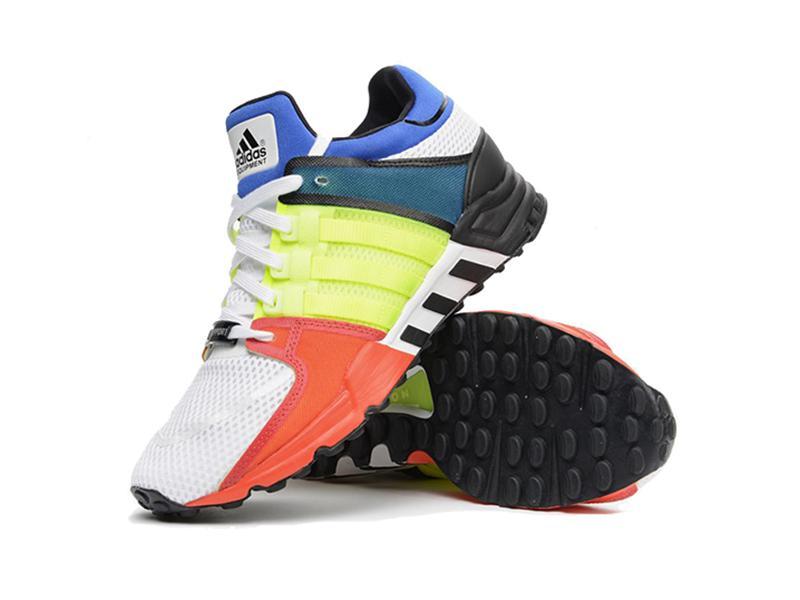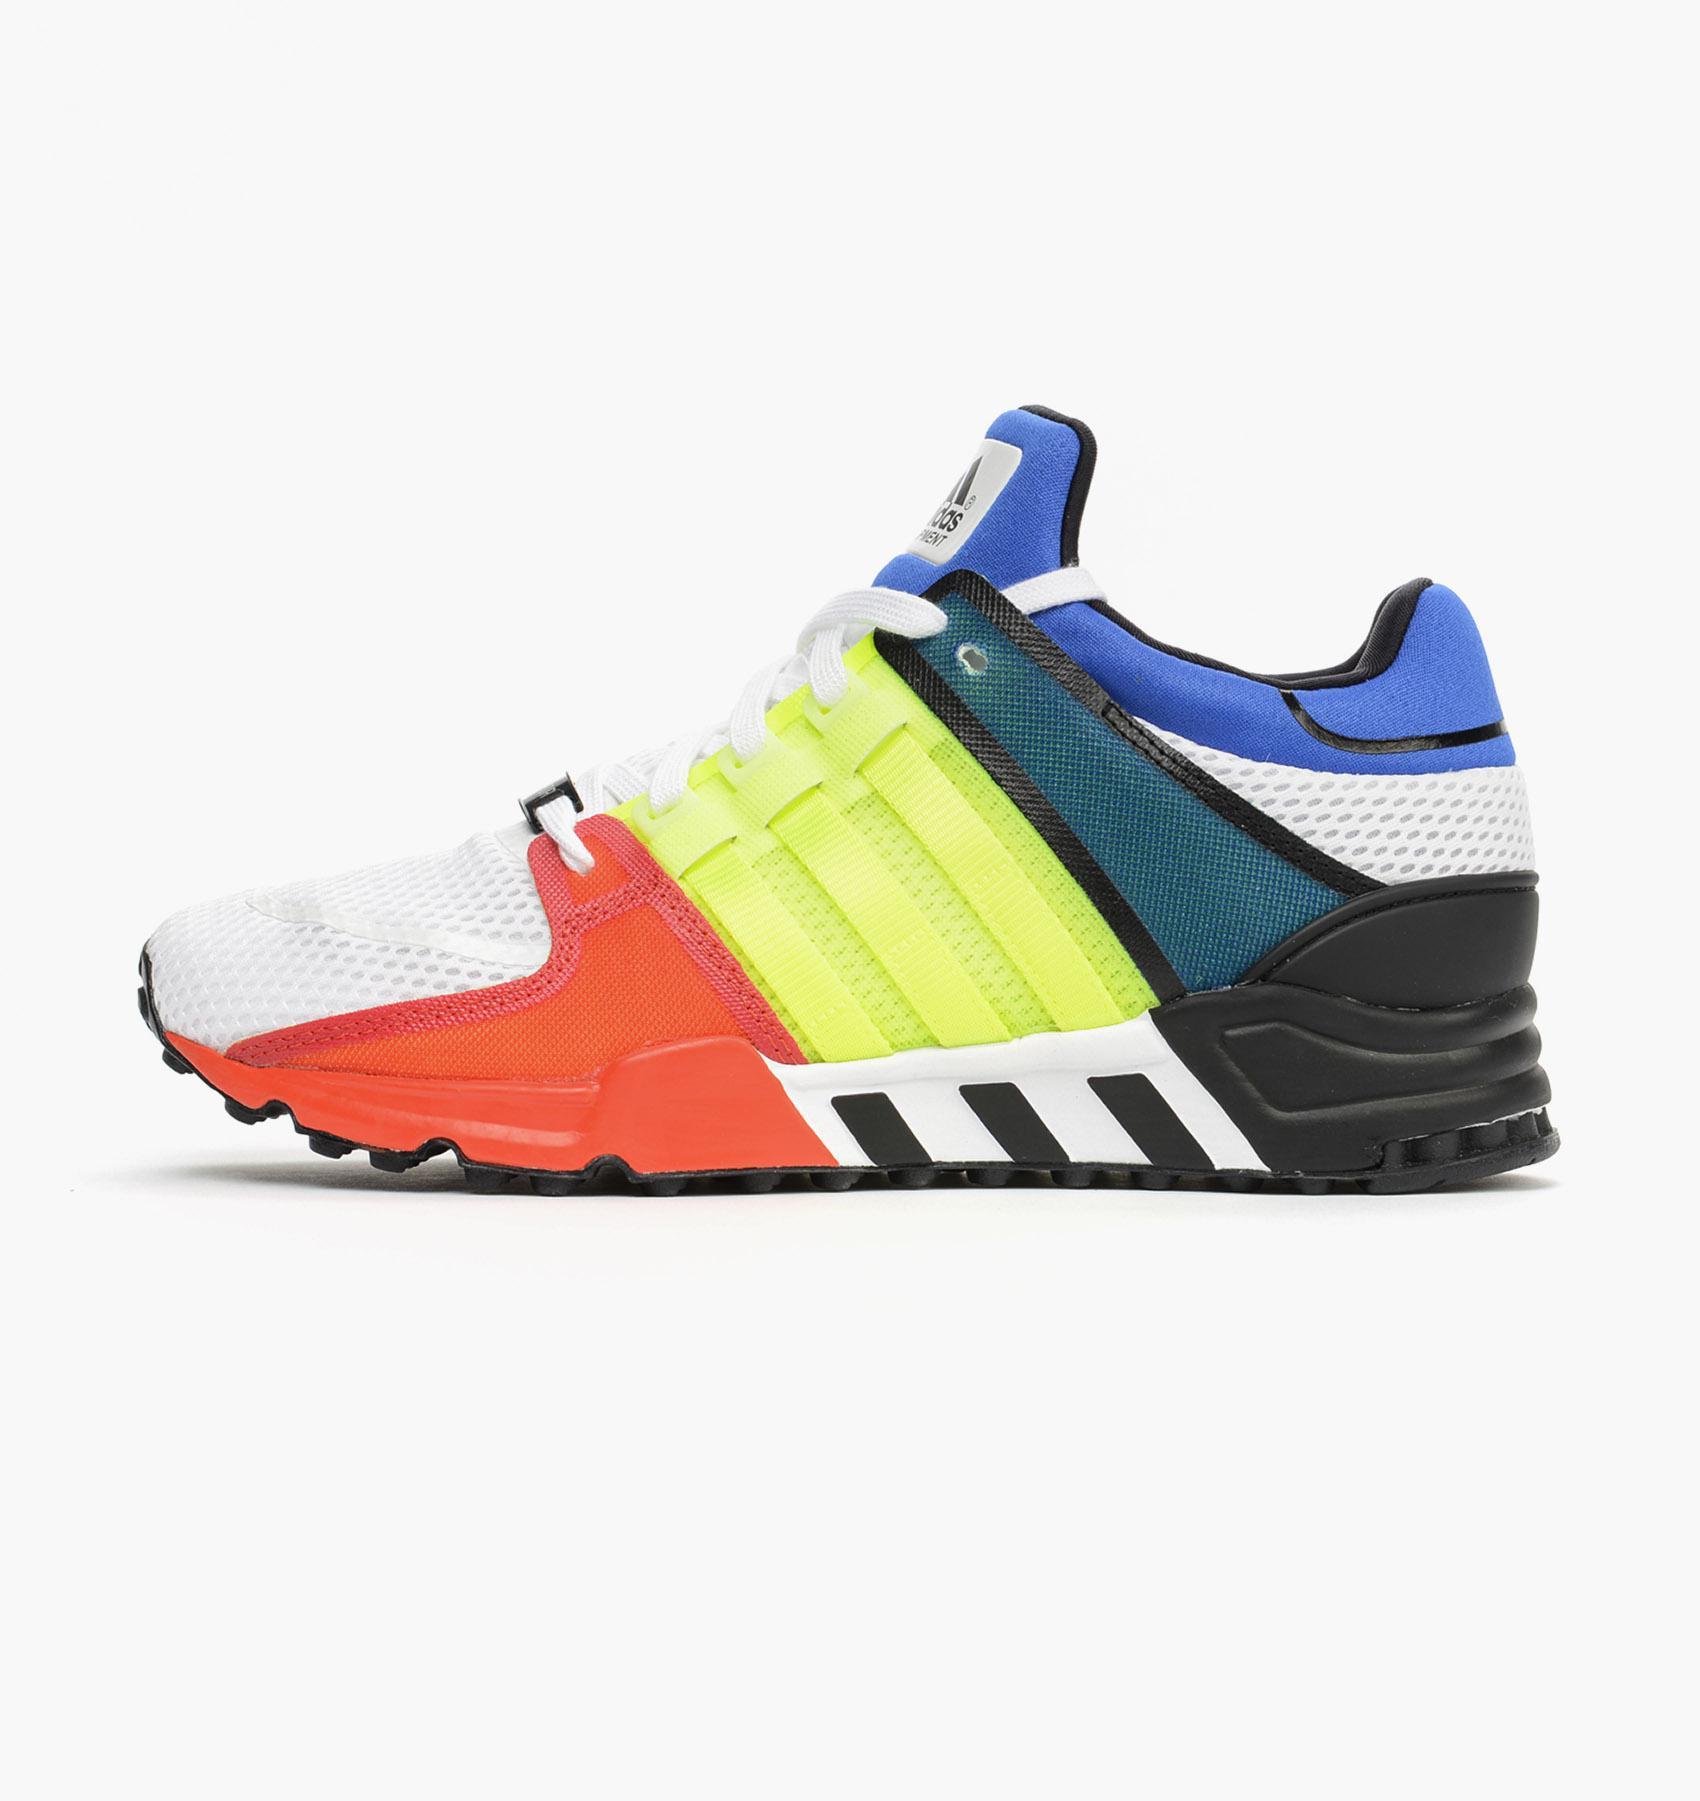The first image is the image on the left, the second image is the image on the right. Considering the images on both sides, is "One image contains a single sneaker, and the other shows a pair of sneakers displayed with a sole-first shoe on its side and a rightside-up shoe leaning in front of it." valid? Answer yes or no. Yes. The first image is the image on the left, the second image is the image on the right. For the images shown, is this caption "One of the images is a single shoe facing left." true? Answer yes or no. Yes. 